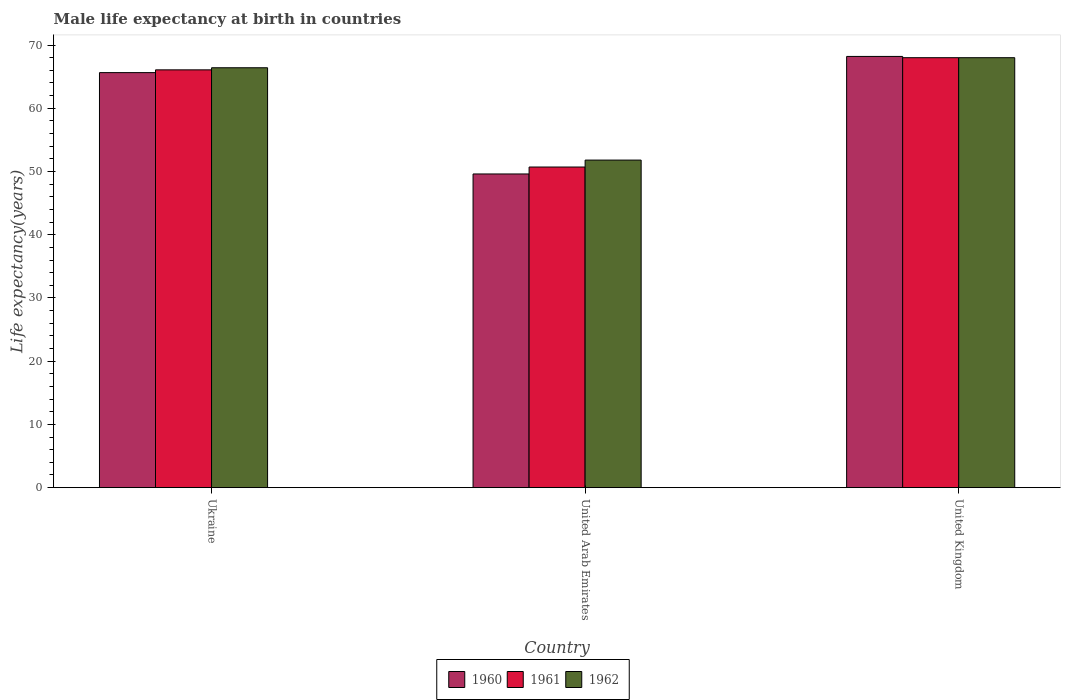How many groups of bars are there?
Your answer should be compact. 3. Are the number of bars per tick equal to the number of legend labels?
Make the answer very short. Yes. How many bars are there on the 2nd tick from the right?
Provide a short and direct response. 3. What is the label of the 2nd group of bars from the left?
Keep it short and to the point. United Arab Emirates. What is the male life expectancy at birth in 1960 in Ukraine?
Keep it short and to the point. 65.64. Across all countries, what is the minimum male life expectancy at birth in 1960?
Offer a very short reply. 49.61. In which country was the male life expectancy at birth in 1961 minimum?
Provide a short and direct response. United Arab Emirates. What is the total male life expectancy at birth in 1961 in the graph?
Your answer should be compact. 184.79. What is the difference between the male life expectancy at birth in 1962 in Ukraine and that in United Arab Emirates?
Give a very brief answer. 14.6. What is the difference between the male life expectancy at birth in 1961 in United Arab Emirates and the male life expectancy at birth in 1960 in United Kingdom?
Make the answer very short. -17.49. What is the average male life expectancy at birth in 1960 per country?
Give a very brief answer. 61.15. What is the difference between the male life expectancy at birth of/in 1961 and male life expectancy at birth of/in 1962 in Ukraine?
Offer a very short reply. -0.33. In how many countries, is the male life expectancy at birth in 1961 greater than 60 years?
Your response must be concise. 2. What is the ratio of the male life expectancy at birth in 1961 in Ukraine to that in United Arab Emirates?
Your answer should be compact. 1.3. Is the difference between the male life expectancy at birth in 1961 in United Arab Emirates and United Kingdom greater than the difference between the male life expectancy at birth in 1962 in United Arab Emirates and United Kingdom?
Your answer should be compact. No. What is the difference between the highest and the second highest male life expectancy at birth in 1962?
Offer a terse response. 14.6. What is the difference between the highest and the lowest male life expectancy at birth in 1962?
Offer a terse response. 16.19. In how many countries, is the male life expectancy at birth in 1962 greater than the average male life expectancy at birth in 1962 taken over all countries?
Provide a short and direct response. 2. What does the 1st bar from the left in Ukraine represents?
Your answer should be compact. 1960. What does the 1st bar from the right in United Arab Emirates represents?
Provide a succinct answer. 1962. Is it the case that in every country, the sum of the male life expectancy at birth in 1961 and male life expectancy at birth in 1962 is greater than the male life expectancy at birth in 1960?
Provide a short and direct response. Yes. What is the difference between two consecutive major ticks on the Y-axis?
Ensure brevity in your answer.  10. Does the graph contain grids?
Keep it short and to the point. No. How are the legend labels stacked?
Keep it short and to the point. Horizontal. What is the title of the graph?
Your response must be concise. Male life expectancy at birth in countries. Does "1997" appear as one of the legend labels in the graph?
Offer a terse response. No. What is the label or title of the Y-axis?
Provide a succinct answer. Life expectancy(years). What is the Life expectancy(years) in 1960 in Ukraine?
Offer a terse response. 65.64. What is the Life expectancy(years) of 1961 in Ukraine?
Offer a very short reply. 66.08. What is the Life expectancy(years) in 1962 in Ukraine?
Make the answer very short. 66.41. What is the Life expectancy(years) in 1960 in United Arab Emirates?
Give a very brief answer. 49.61. What is the Life expectancy(years) of 1961 in United Arab Emirates?
Provide a succinct answer. 50.71. What is the Life expectancy(years) in 1962 in United Arab Emirates?
Provide a short and direct response. 51.81. What is the Life expectancy(years) in 1960 in United Kingdom?
Keep it short and to the point. 68.2. What is the Life expectancy(years) in 1962 in United Kingdom?
Offer a terse response. 68. Across all countries, what is the maximum Life expectancy(years) of 1960?
Make the answer very short. 68.2. Across all countries, what is the maximum Life expectancy(years) in 1961?
Keep it short and to the point. 68. Across all countries, what is the minimum Life expectancy(years) of 1960?
Give a very brief answer. 49.61. Across all countries, what is the minimum Life expectancy(years) of 1961?
Provide a succinct answer. 50.71. Across all countries, what is the minimum Life expectancy(years) of 1962?
Offer a terse response. 51.81. What is the total Life expectancy(years) of 1960 in the graph?
Ensure brevity in your answer.  183.45. What is the total Life expectancy(years) of 1961 in the graph?
Offer a very short reply. 184.79. What is the total Life expectancy(years) in 1962 in the graph?
Provide a short and direct response. 186.22. What is the difference between the Life expectancy(years) of 1960 in Ukraine and that in United Arab Emirates?
Your answer should be very brief. 16.03. What is the difference between the Life expectancy(years) of 1961 in Ukraine and that in United Arab Emirates?
Keep it short and to the point. 15.37. What is the difference between the Life expectancy(years) in 1962 in Ukraine and that in United Arab Emirates?
Provide a succinct answer. 14.6. What is the difference between the Life expectancy(years) of 1960 in Ukraine and that in United Kingdom?
Make the answer very short. -2.56. What is the difference between the Life expectancy(years) in 1961 in Ukraine and that in United Kingdom?
Offer a terse response. -1.92. What is the difference between the Life expectancy(years) in 1962 in Ukraine and that in United Kingdom?
Give a very brief answer. -1.59. What is the difference between the Life expectancy(years) of 1960 in United Arab Emirates and that in United Kingdom?
Offer a very short reply. -18.59. What is the difference between the Life expectancy(years) in 1961 in United Arab Emirates and that in United Kingdom?
Keep it short and to the point. -17.29. What is the difference between the Life expectancy(years) of 1962 in United Arab Emirates and that in United Kingdom?
Offer a terse response. -16.19. What is the difference between the Life expectancy(years) in 1960 in Ukraine and the Life expectancy(years) in 1961 in United Arab Emirates?
Keep it short and to the point. 14.93. What is the difference between the Life expectancy(years) in 1960 in Ukraine and the Life expectancy(years) in 1962 in United Arab Emirates?
Offer a terse response. 13.83. What is the difference between the Life expectancy(years) of 1961 in Ukraine and the Life expectancy(years) of 1962 in United Arab Emirates?
Give a very brief answer. 14.27. What is the difference between the Life expectancy(years) of 1960 in Ukraine and the Life expectancy(years) of 1961 in United Kingdom?
Your answer should be compact. -2.36. What is the difference between the Life expectancy(years) of 1960 in Ukraine and the Life expectancy(years) of 1962 in United Kingdom?
Make the answer very short. -2.36. What is the difference between the Life expectancy(years) of 1961 in Ukraine and the Life expectancy(years) of 1962 in United Kingdom?
Give a very brief answer. -1.92. What is the difference between the Life expectancy(years) of 1960 in United Arab Emirates and the Life expectancy(years) of 1961 in United Kingdom?
Give a very brief answer. -18.39. What is the difference between the Life expectancy(years) in 1960 in United Arab Emirates and the Life expectancy(years) in 1962 in United Kingdom?
Give a very brief answer. -18.39. What is the difference between the Life expectancy(years) in 1961 in United Arab Emirates and the Life expectancy(years) in 1962 in United Kingdom?
Ensure brevity in your answer.  -17.29. What is the average Life expectancy(years) in 1960 per country?
Your response must be concise. 61.15. What is the average Life expectancy(years) of 1961 per country?
Your answer should be very brief. 61.6. What is the average Life expectancy(years) of 1962 per country?
Keep it short and to the point. 62.07. What is the difference between the Life expectancy(years) in 1960 and Life expectancy(years) in 1961 in Ukraine?
Give a very brief answer. -0.44. What is the difference between the Life expectancy(years) in 1960 and Life expectancy(years) in 1962 in Ukraine?
Offer a terse response. -0.77. What is the difference between the Life expectancy(years) of 1961 and Life expectancy(years) of 1962 in Ukraine?
Offer a very short reply. -0.33. What is the difference between the Life expectancy(years) in 1960 and Life expectancy(years) in 1961 in United Arab Emirates?
Provide a short and direct response. -1.1. What is the difference between the Life expectancy(years) of 1960 and Life expectancy(years) of 1962 in United Arab Emirates?
Your response must be concise. -2.19. What is the difference between the Life expectancy(years) in 1961 and Life expectancy(years) in 1962 in United Arab Emirates?
Give a very brief answer. -1.1. What is the difference between the Life expectancy(years) of 1960 and Life expectancy(years) of 1962 in United Kingdom?
Make the answer very short. 0.2. What is the ratio of the Life expectancy(years) of 1960 in Ukraine to that in United Arab Emirates?
Make the answer very short. 1.32. What is the ratio of the Life expectancy(years) in 1961 in Ukraine to that in United Arab Emirates?
Your answer should be compact. 1.3. What is the ratio of the Life expectancy(years) of 1962 in Ukraine to that in United Arab Emirates?
Your answer should be very brief. 1.28. What is the ratio of the Life expectancy(years) of 1960 in Ukraine to that in United Kingdom?
Your answer should be very brief. 0.96. What is the ratio of the Life expectancy(years) in 1961 in Ukraine to that in United Kingdom?
Offer a terse response. 0.97. What is the ratio of the Life expectancy(years) of 1962 in Ukraine to that in United Kingdom?
Offer a very short reply. 0.98. What is the ratio of the Life expectancy(years) in 1960 in United Arab Emirates to that in United Kingdom?
Provide a short and direct response. 0.73. What is the ratio of the Life expectancy(years) of 1961 in United Arab Emirates to that in United Kingdom?
Make the answer very short. 0.75. What is the ratio of the Life expectancy(years) in 1962 in United Arab Emirates to that in United Kingdom?
Offer a very short reply. 0.76. What is the difference between the highest and the second highest Life expectancy(years) of 1960?
Make the answer very short. 2.56. What is the difference between the highest and the second highest Life expectancy(years) in 1961?
Offer a terse response. 1.92. What is the difference between the highest and the second highest Life expectancy(years) in 1962?
Your response must be concise. 1.59. What is the difference between the highest and the lowest Life expectancy(years) of 1960?
Your response must be concise. 18.59. What is the difference between the highest and the lowest Life expectancy(years) in 1961?
Offer a terse response. 17.29. What is the difference between the highest and the lowest Life expectancy(years) of 1962?
Your answer should be very brief. 16.19. 